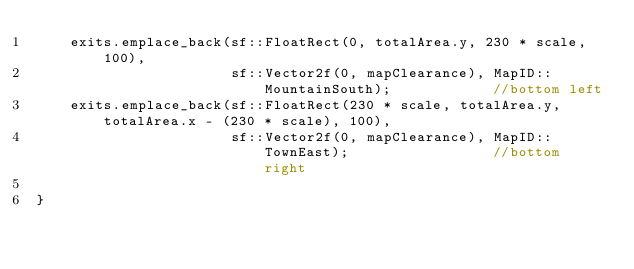Convert code to text. <code><loc_0><loc_0><loc_500><loc_500><_C++_>	exits.emplace_back(sf::FloatRect(0, totalArea.y, 230 * scale, 100),
					   sf::Vector2f(0, mapClearance), MapID::MountainSouth);			//bottom left
	exits.emplace_back(sf::FloatRect(230 * scale, totalArea.y, totalArea.x - (230 * scale), 100),
					   sf::Vector2f(0, mapClearance), MapID::TownEast);					//bottom right
	
}
</code> 